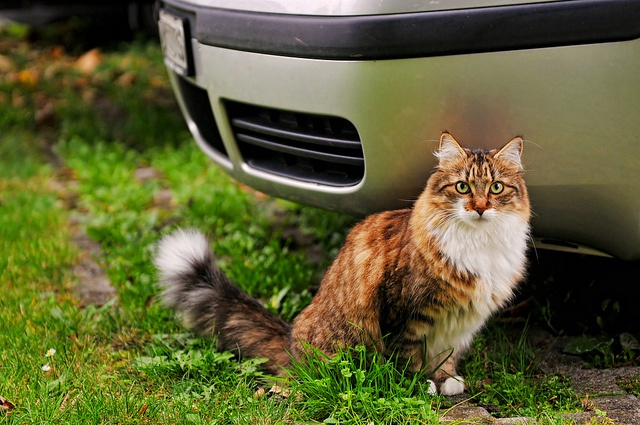Describe the objects in this image and their specific colors. I can see car in black, gray, olive, and darkgray tones and cat in black, brown, olive, and maroon tones in this image. 